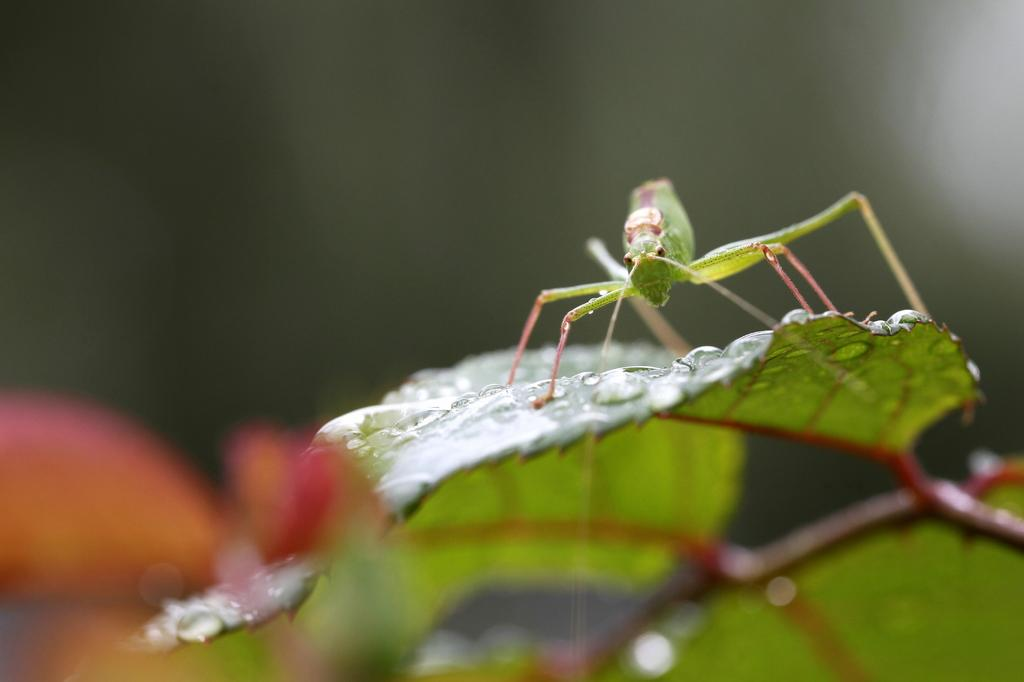What is the main subject of the image? The main subject of the image is a cricket. Where is the cricket located? The cricket is on a leaf in the image. Can you describe the background of the image? The background of the image is blurred. What type of flesh can be seen on the cricket in the image? There is no flesh visible on the cricket in the image; it is an insect with an exoskeleton. 